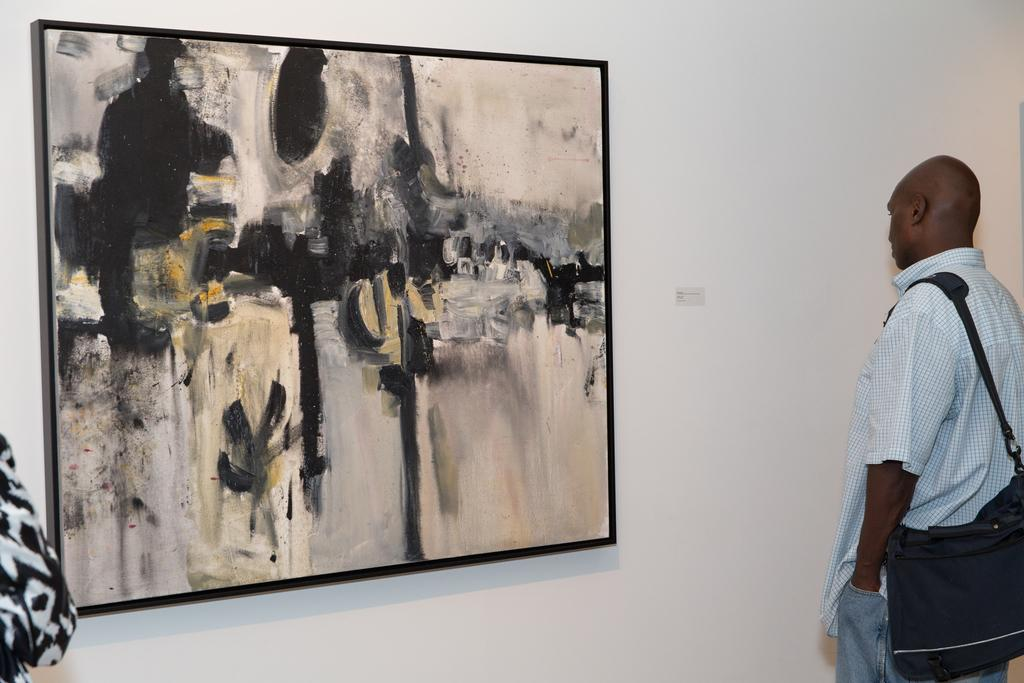What is the primary subject of the image? There is a person standing in the image. What is the person wearing that is visible in the image? The person is wearing a bag. Are there any other people present in the image? Yes, there is another person in the image. What can be seen on the wall in the image? There is a frame on the wall in the image. What type of leather can be seen on the person's toes in the image? There is no leather or mention of toes in the image; the person is wearing a bag. 